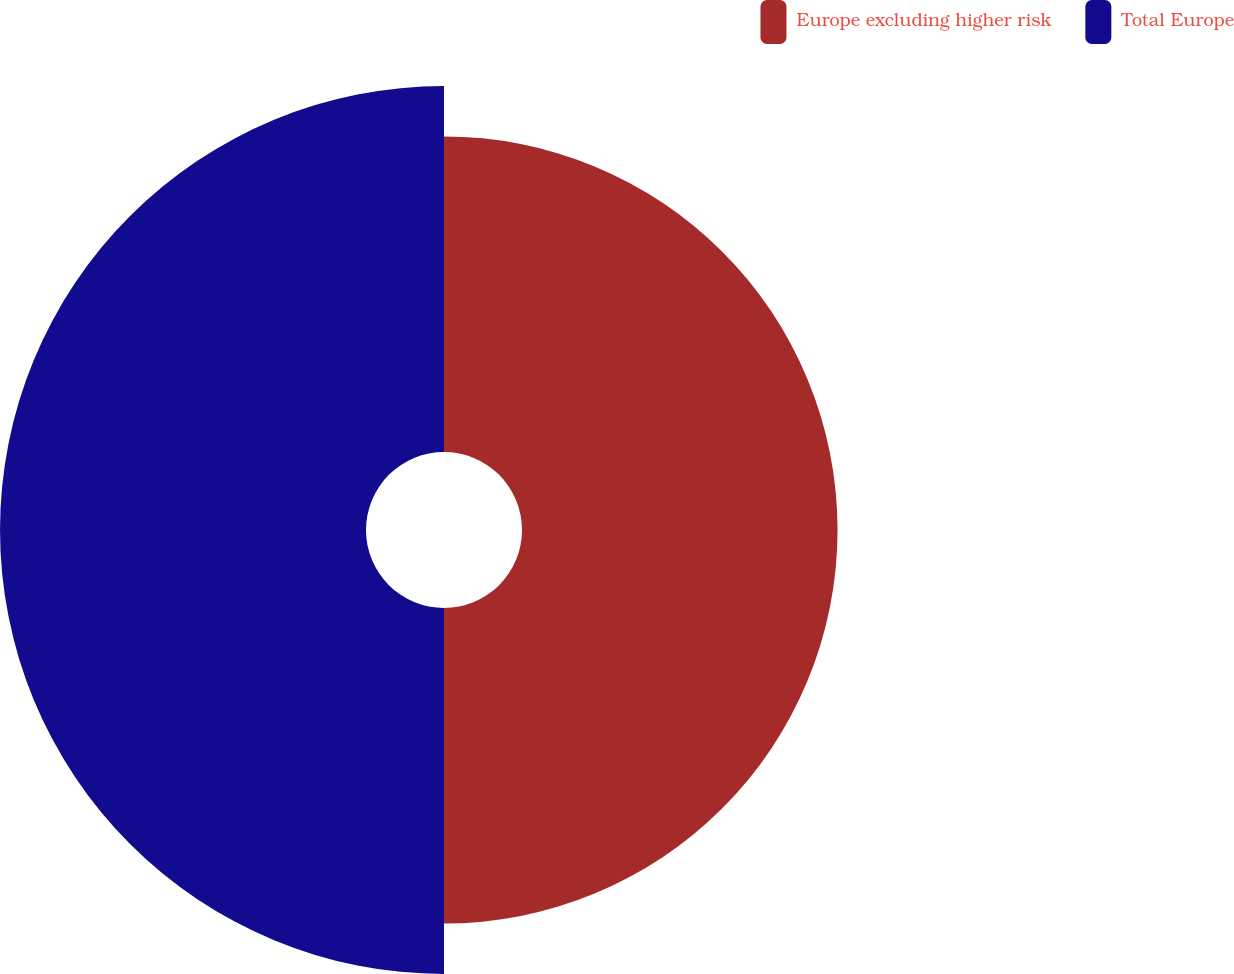Convert chart to OTSL. <chart><loc_0><loc_0><loc_500><loc_500><pie_chart><fcel>Europe excluding higher risk<fcel>Total Europe<nl><fcel>46.3%<fcel>53.7%<nl></chart> 